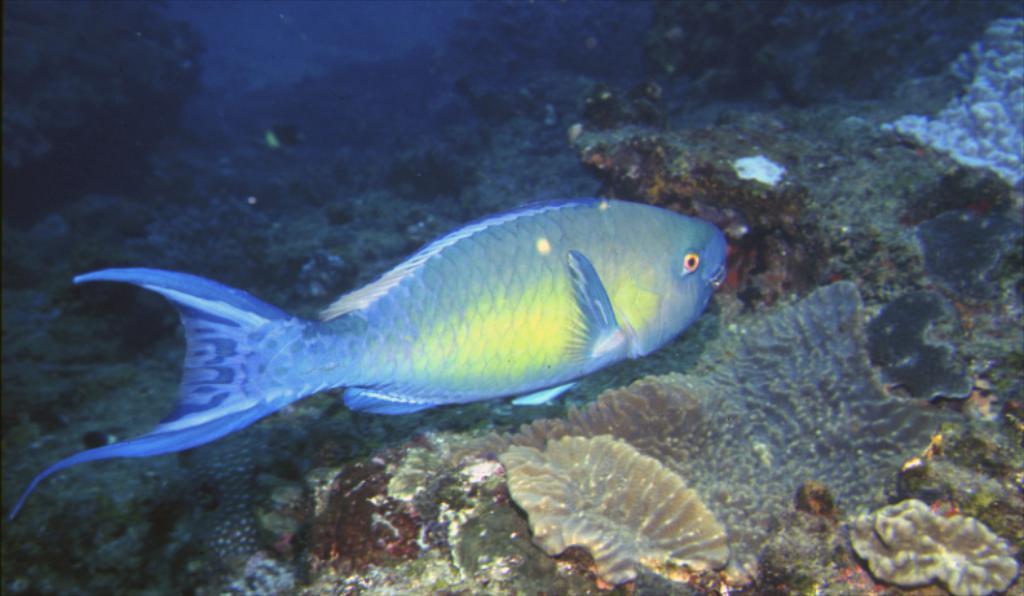Could you give a brief overview of what you see in this image? In this image, we can see a fish in the water. 